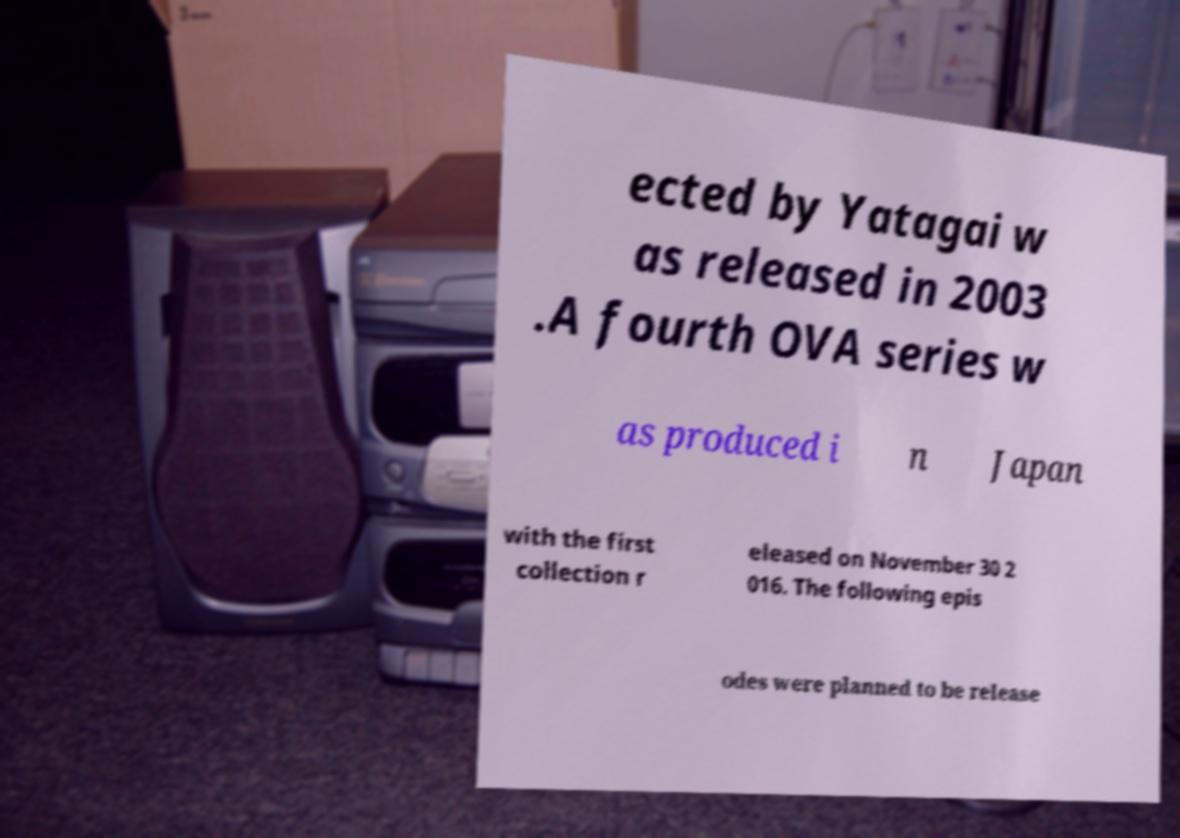Please identify and transcribe the text found in this image. ected by Yatagai w as released in 2003 .A fourth OVA series w as produced i n Japan with the first collection r eleased on November 30 2 016. The following epis odes were planned to be release 